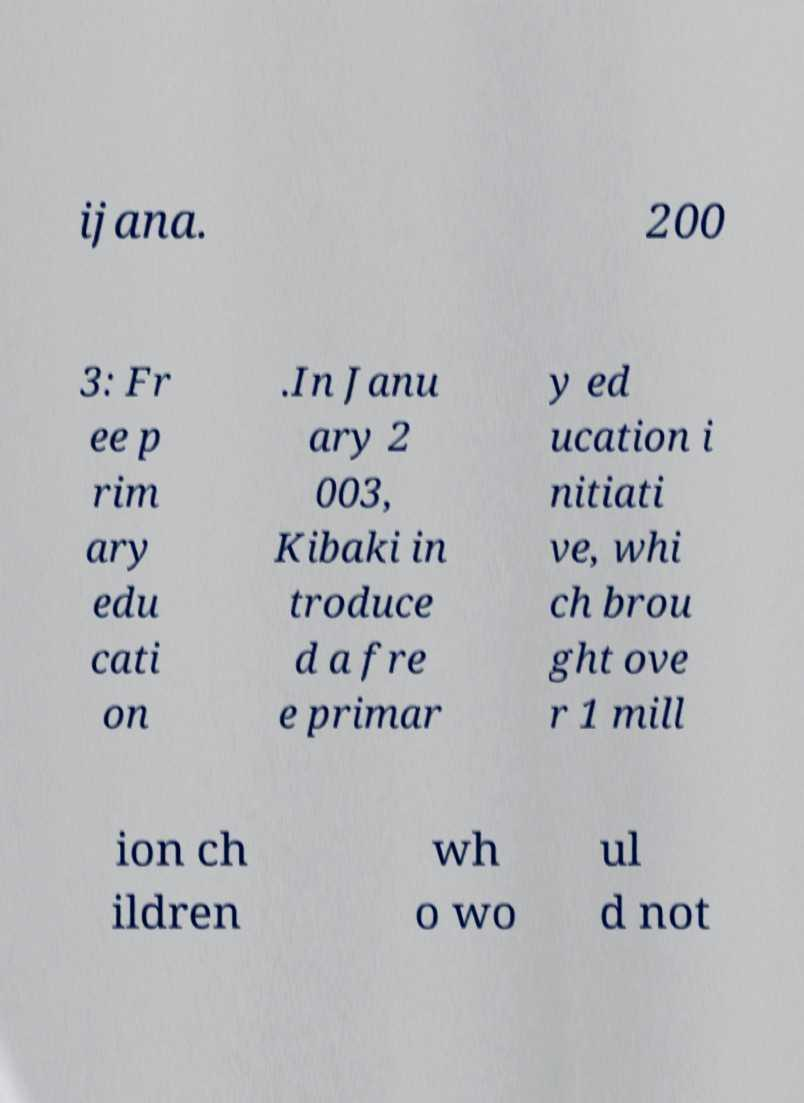What messages or text are displayed in this image? I need them in a readable, typed format. ijana. 200 3: Fr ee p rim ary edu cati on .In Janu ary 2 003, Kibaki in troduce d a fre e primar y ed ucation i nitiati ve, whi ch brou ght ove r 1 mill ion ch ildren wh o wo ul d not 